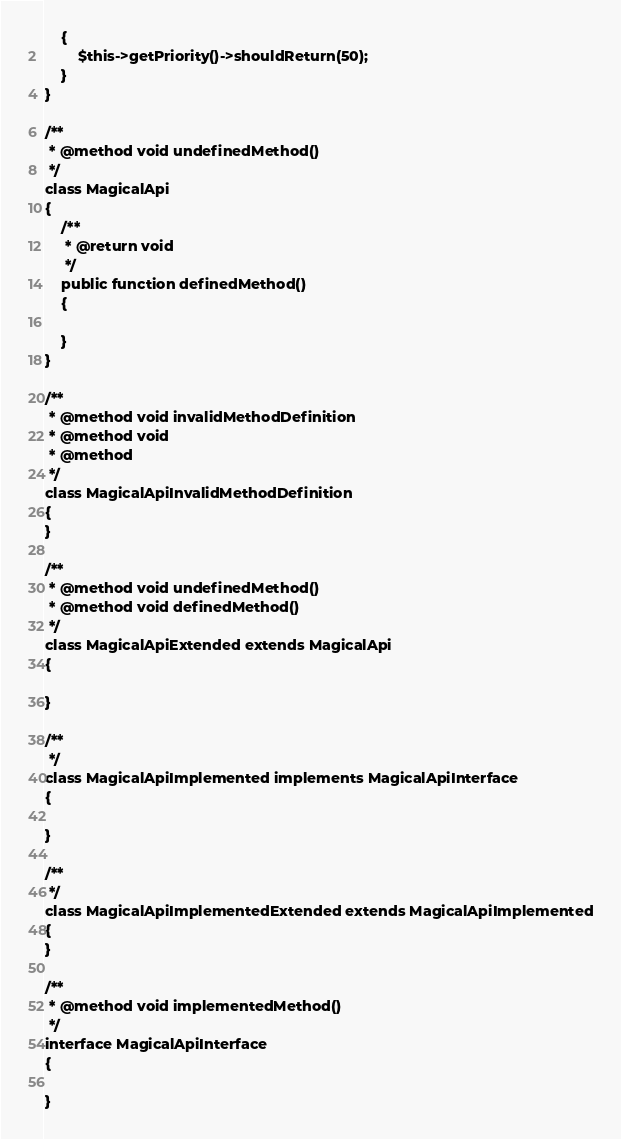Convert code to text. <code><loc_0><loc_0><loc_500><loc_500><_PHP_>    {
        $this->getPriority()->shouldReturn(50);
    }
}

/**
 * @method void undefinedMethod()
 */
class MagicalApi
{
    /**
     * @return void
     */
    public function definedMethod()
    {

    }
}

/**
 * @method void invalidMethodDefinition
 * @method void
 * @method
 */
class MagicalApiInvalidMethodDefinition
{
}

/**
 * @method void undefinedMethod()
 * @method void definedMethod()
 */
class MagicalApiExtended extends MagicalApi
{

}

/**
 */
class MagicalApiImplemented implements MagicalApiInterface
{

}

/**
 */
class MagicalApiImplementedExtended extends MagicalApiImplemented
{
}

/**
 * @method void implementedMethod()
 */
interface MagicalApiInterface
{

}
</code> 